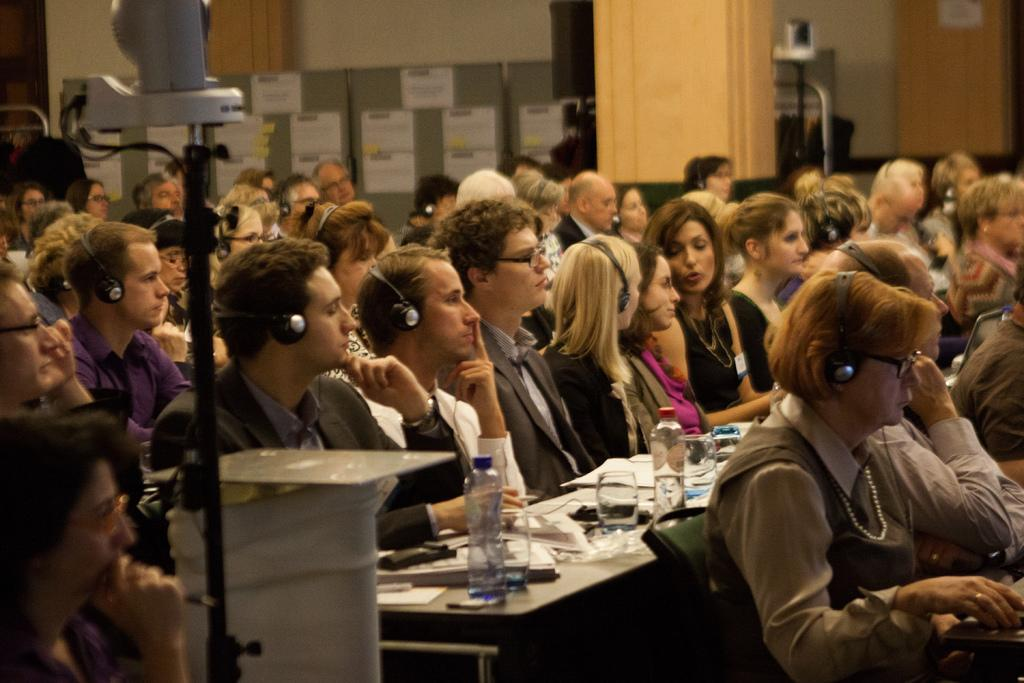What is one of the main features of the image? There is a wall in the image. What object is used for capturing images in the scene? There is a camera in the image. What items can be seen on the tables in the image? On the tables, there are papers, books, bottles, and glasses. What are the people in the image wearing? The people are wearing headsets. How are the people arranged in the image? There is a group of people sitting on chairs in the image. What type of fear can be seen on the faces of the people in the image? There is no indication of fear on the faces of the people in the image. Where is the nearest park to the location depicted in the image? The image does not provide information about the location or the nearest park. 